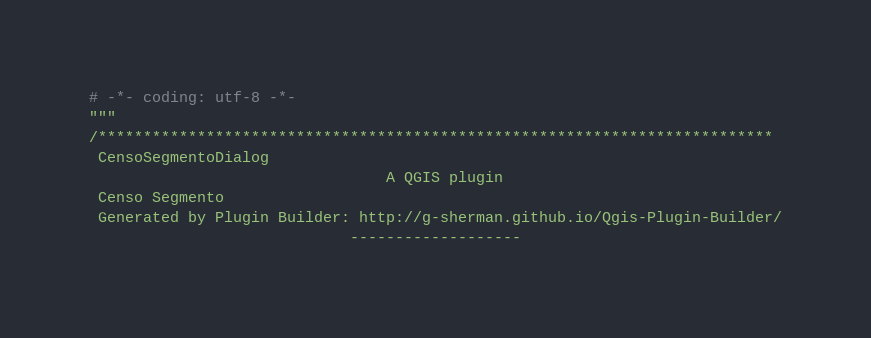Convert code to text. <code><loc_0><loc_0><loc_500><loc_500><_Python_># -*- coding: utf-8 -*-
"""
/***************************************************************************
 CensoSegmentoDialog
                                 A QGIS plugin
 Censo Segmento
 Generated by Plugin Builder: http://g-sherman.github.io/Qgis-Plugin-Builder/
                             -------------------</code> 